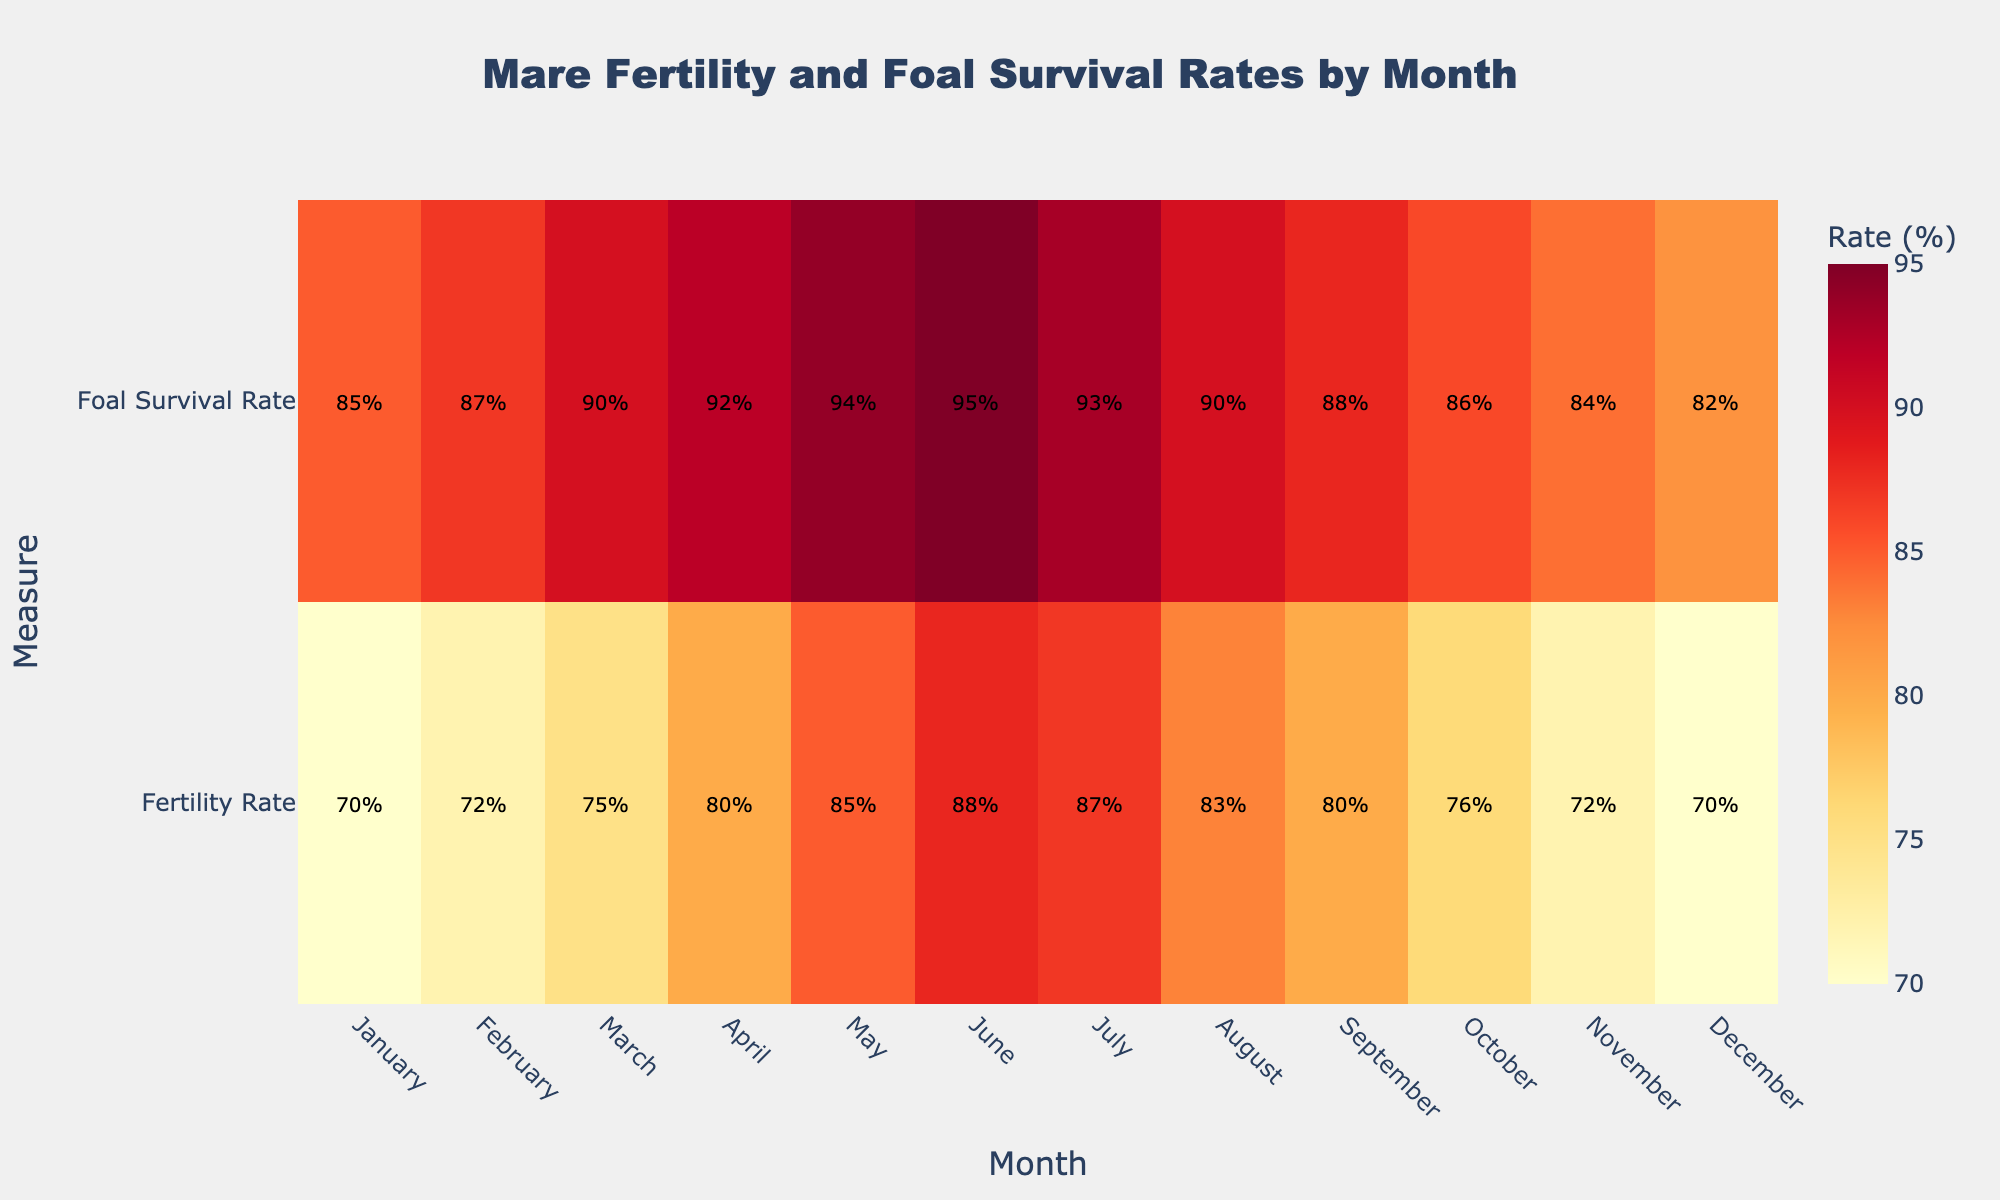What is the title of the figure? The title is usually located at the top of the figure. It summarizes what the figure is about. Here, it clearly states the focus on mare fertility and foal survival rates by month.
Answer: 'Mare Fertility and Foal Survival Rates by Month' Which month has the highest fertility rate for mares? Look at the row corresponding to 'Fertility Rate' and identify the month where the value is highest.
Answer: June Which month shows the highest foal survival rate? Look at the row corresponding to 'Foal Survival Rate' and find the month with the maximum percentage.
Answer: June How do the fertility and foal survival rates compare in July? Locate the values for July in both the 'Fertility Rate' and 'Foal Survival Rate' rows, then compare them directly.
Answer: Fertility Rate: 87%, Foal Survival Rate: 93% What is the average fertility rate across all months? Sum the fertility rates for all months and then divide by 12 (number of months). Calculations: (70 + 72 + 75 + 80 + 85 + 88 + 87 + 83 + 80 + 76 + 72 + 70)/12 = 79.33
Answer: 79.33% In which month is the difference between fertility and foal survival rates the smallest? For each month, calculate the absolute difference between fertility rates and foal survival rates, then find the month with the smallest difference:
Answer: July (6%) Is there a month where the foal survival rate is exactly 90%? Check the values for 'Foal Survival Rate' across all months to see if 90% appears.
Answer: Yes, in March and August How does the fertility rate trend change from January to December? Observe the fertility rate values from January to December to determine the general trend.
Answer: Decreases initially, increases until June, then decreases again Which month has the lowest foal survival rate, and what is it? Identify the month with the minimum value in the 'Foal Survival Rate' row and note the corresponding rate.
Answer: December, 82% What is the combined (sum) rate of fertility and foal survival in April? Add the fertility rate and foal survival rate for April: 80% + 92% = 172%
Answer: 172% 